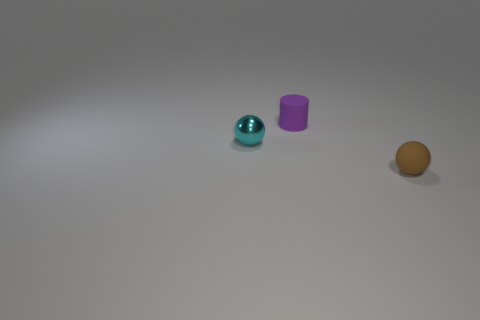Are the small sphere that is to the right of the purple cylinder and the tiny purple cylinder made of the same material?
Offer a terse response. Yes. How many small objects are balls or matte cylinders?
Offer a terse response. 3. Do the matte ball and the tiny rubber cylinder have the same color?
Keep it short and to the point. No. Is the number of objects that are in front of the small cyan ball greater than the number of brown matte things behind the purple cylinder?
Give a very brief answer. Yes. There is a matte thing that is behind the cyan shiny object; does it have the same color as the tiny rubber sphere?
Provide a succinct answer. No. Is there anything else that has the same color as the shiny thing?
Provide a succinct answer. No. Are there more rubber objects right of the cyan shiny object than tiny gray rubber blocks?
Keep it short and to the point. Yes. Is the purple rubber thing the same size as the metallic sphere?
Keep it short and to the point. Yes. There is another tiny object that is the same shape as the cyan metal object; what material is it?
Offer a very short reply. Rubber. Is there anything else that has the same material as the purple cylinder?
Make the answer very short. Yes. 